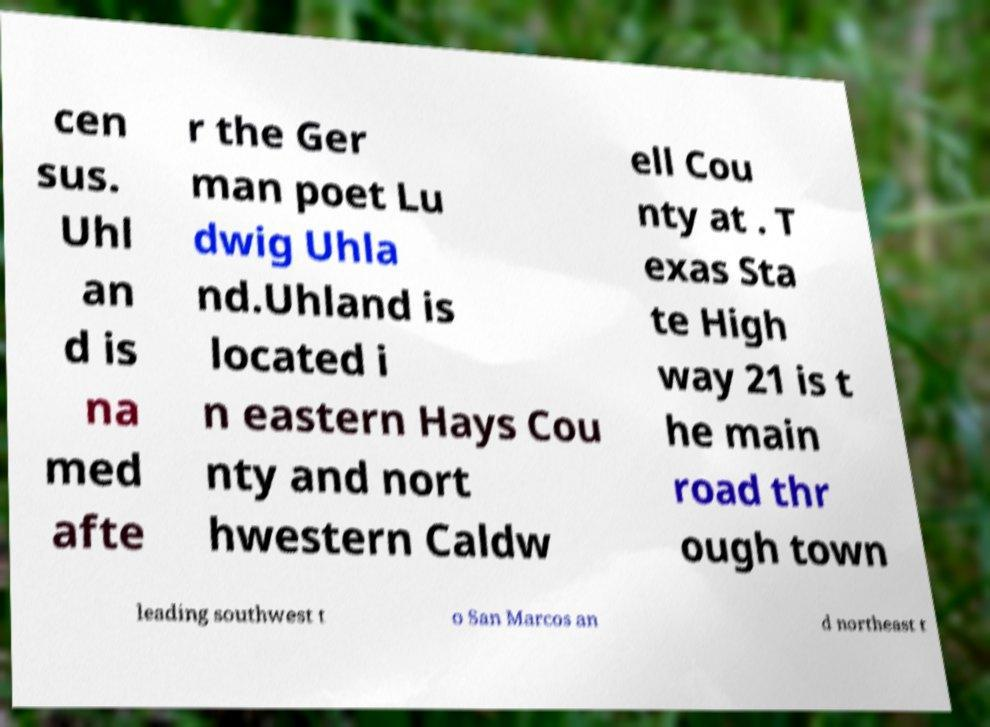There's text embedded in this image that I need extracted. Can you transcribe it verbatim? cen sus. Uhl an d is na med afte r the Ger man poet Lu dwig Uhla nd.Uhland is located i n eastern Hays Cou nty and nort hwestern Caldw ell Cou nty at . T exas Sta te High way 21 is t he main road thr ough town leading southwest t o San Marcos an d northeast t 